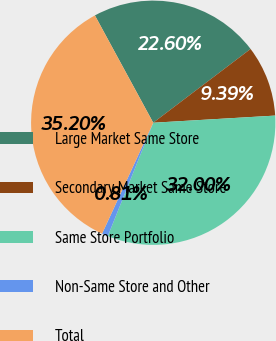Convert chart. <chart><loc_0><loc_0><loc_500><loc_500><pie_chart><fcel>Large Market Same Store<fcel>Secondary Market Same Store<fcel>Same Store Portfolio<fcel>Non-Same Store and Other<fcel>Total<nl><fcel>22.6%<fcel>9.39%<fcel>32.0%<fcel>0.81%<fcel>35.2%<nl></chart> 